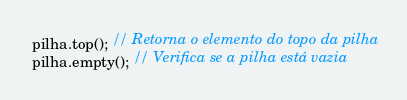<code> <loc_0><loc_0><loc_500><loc_500><_C++_>pilha.top(); // Retorna o elemento do topo da pilha
pilha.empty(); // Verifica se a pilha está vazia</code> 